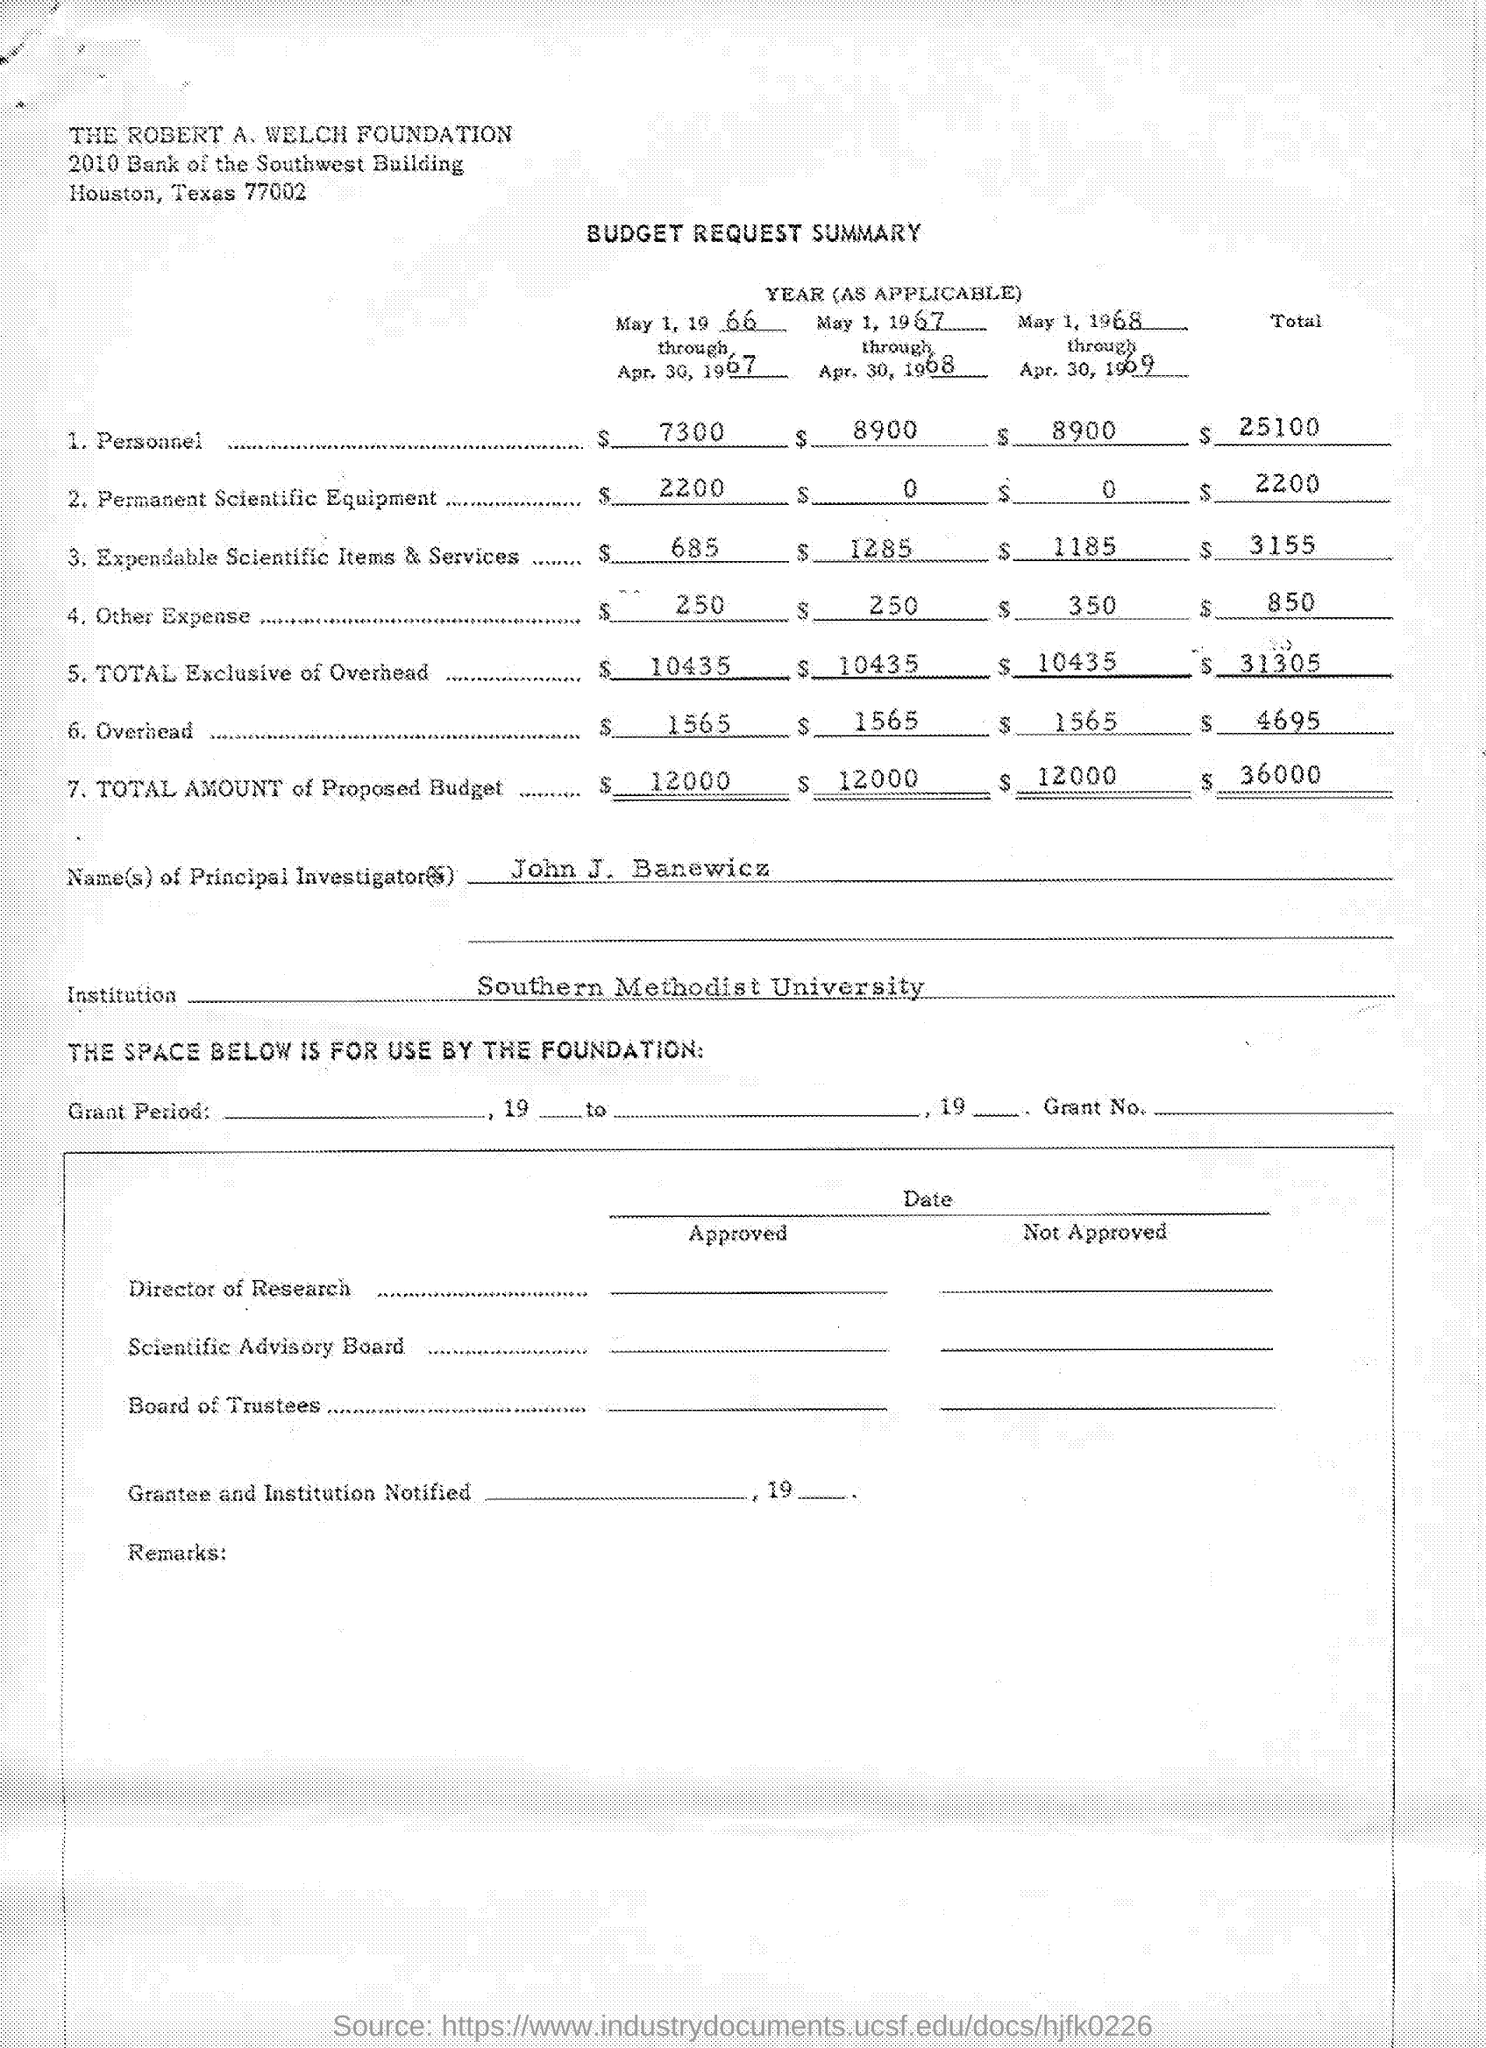What is the Title of the Document?
Provide a short and direct response. BUDGET REQUEST SUMMARY. What is the Budget for Personnel for May 1, 1966 through Apr. 30, 1967?
Your answer should be compact. $7300. What is the Budget for Permanent Scientific Equipment for May 1, 1966 through Apr. 30, 1967?
Provide a succinct answer. $2200. What is the Budget for Expendable Scientific Items and Services for May 1, 1966 through Apr. 30, 1967?
Provide a succinct answer. $685. What is the Budget for Other Expenses for May 1, 1966 through Apr. 30, 1967?
Offer a terse response. $250. What is the Budget for Total Exclusive of Overhead for May 1, 1966 through Apr. 30, 1967?
Provide a short and direct response. $10,435. What is the Budget for Overhead for May 1, 1966 through Apr. 30, 1967?
Provide a short and direct response. $1565. What is the Total amount of Proposed Budget  for May 1, 1966 through Apr. 30, 1967?
Give a very brief answer. $12,000. What is the Name of Principal Investigator?
Provide a short and direct response. John J. Banewicz. 